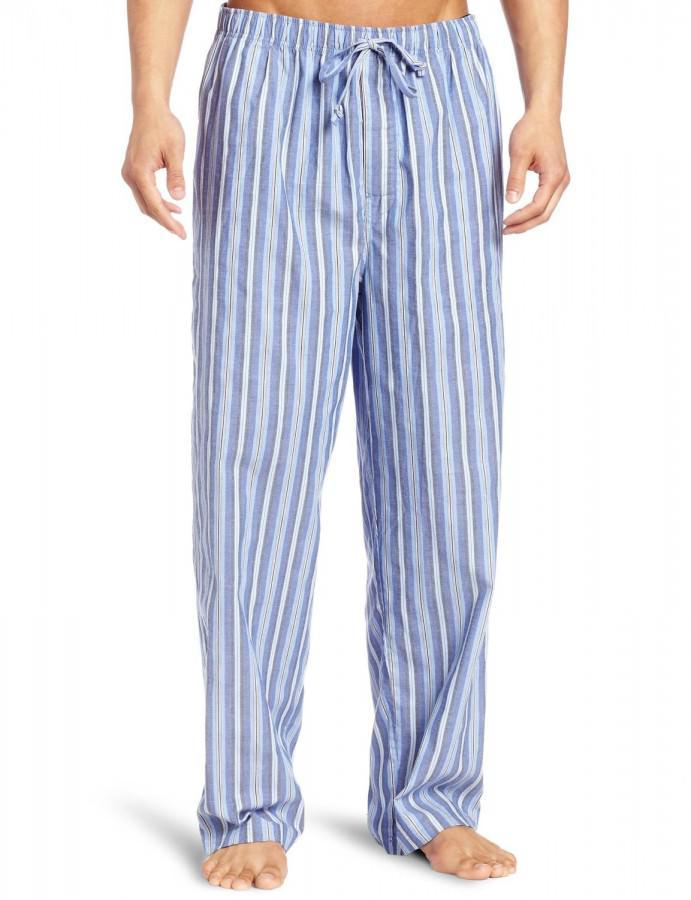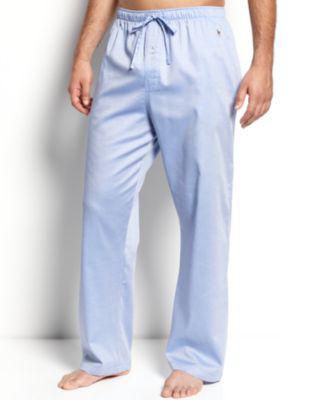The first image is the image on the left, the second image is the image on the right. Considering the images on both sides, is "The image on the left has a man's leg bending to the right with his heel up." valid? Answer yes or no. No. 